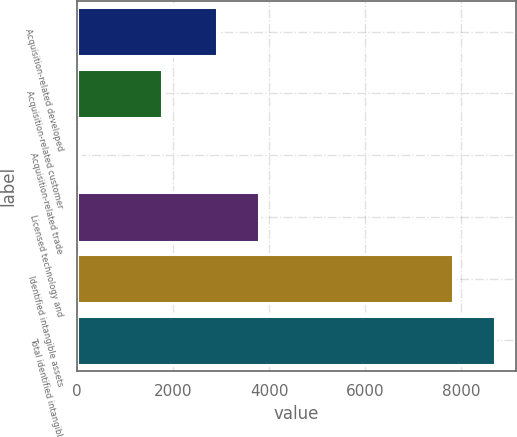Convert chart to OTSL. <chart><loc_0><loc_0><loc_500><loc_500><bar_chart><fcel>Acquisition-related developed<fcel>Acquisition-related customer<fcel>Acquisition-related trade<fcel>Licensed technology and<fcel>Identified intangible assets<fcel>Total identified intangible<nl><fcel>2922<fcel>1760<fcel>65<fcel>3784.2<fcel>7840<fcel>8702.2<nl></chart> 